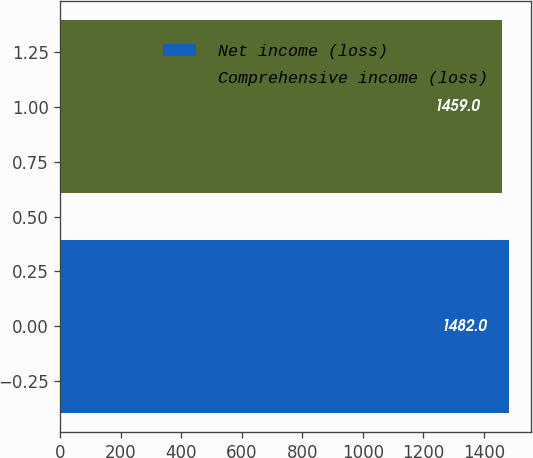Convert chart to OTSL. <chart><loc_0><loc_0><loc_500><loc_500><bar_chart><fcel>Net income (loss)<fcel>Comprehensive income (loss)<nl><fcel>1482<fcel>1459<nl></chart> 